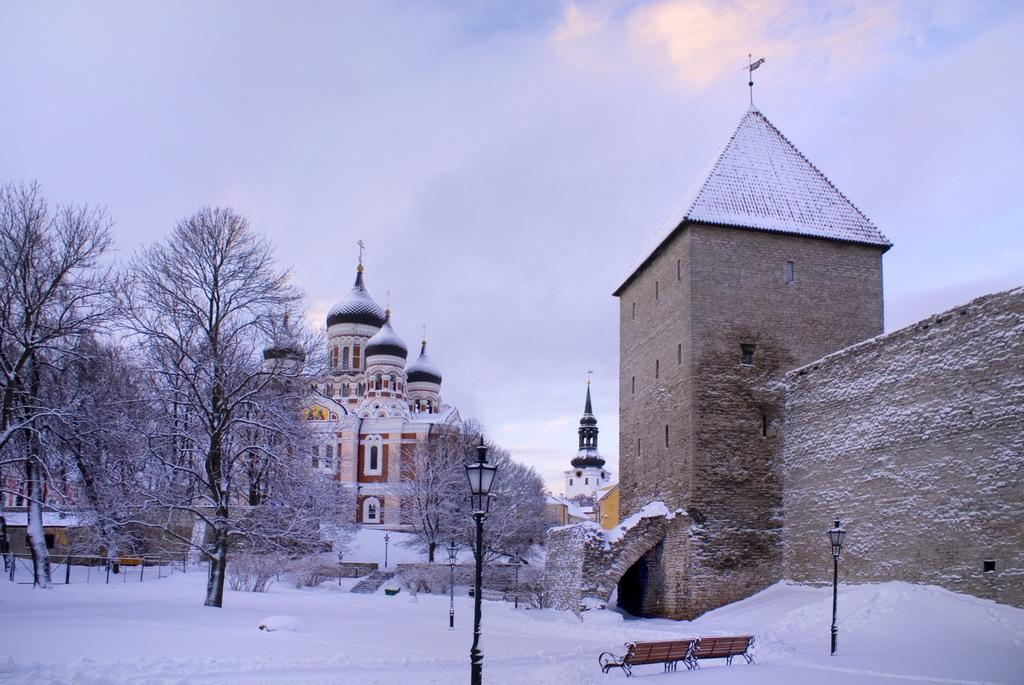What type of structures can be seen in the image? There are buildings and a castle in the image. What other elements can be found in the image? There are trees, street poles, street lights, and benches covered with snow in the image. What is visible in the background of the image? The sky is visible in the background of the image. What can be observed in the sky? Clouds are present in the sky. Where is the shelf located in the image? There is no shelf present in the image. What type of water can be seen flowing through the castle in the image? There is no water flowing through the castle in the image. 